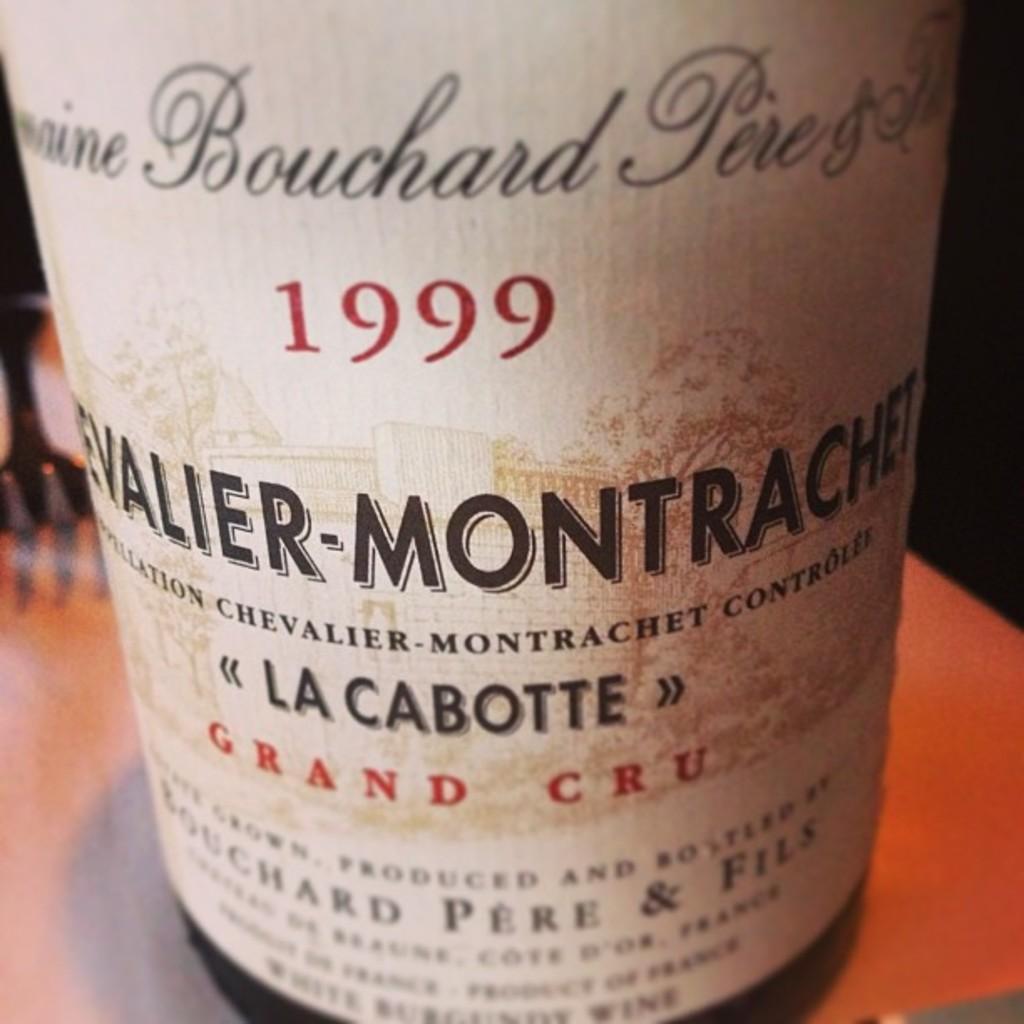Can you describe this image briefly? In the picture I can see a bottle on a surface. On this bottle label I can see something written on it. 